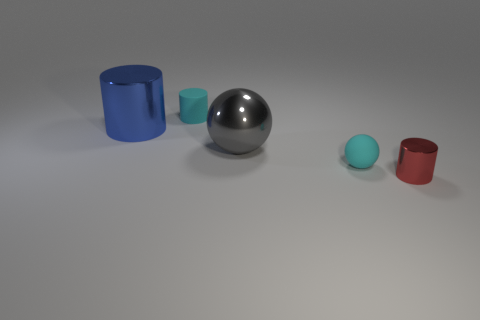What number of things have the same color as the small rubber ball?
Your answer should be very brief. 1. There is a rubber thing that is in front of the tiny object behind the cylinder that is to the left of the rubber cylinder; how big is it?
Ensure brevity in your answer.  Small. How many small cylinders are behind the red metallic cylinder?
Offer a terse response. 1. Is the number of tiny rubber balls greater than the number of brown balls?
Your answer should be very brief. Yes. There is a rubber object that is the same color as the tiny rubber cylinder; what is its size?
Keep it short and to the point. Small. How big is the cylinder that is both in front of the small rubber cylinder and to the left of the matte ball?
Give a very brief answer. Large. There is a tiny cylinder that is in front of the big blue metal object that is behind the big object in front of the blue shiny object; what is its material?
Your answer should be compact. Metal. There is a small object that is the same color as the tiny matte ball; what is it made of?
Your answer should be compact. Rubber. Does the tiny rubber cylinder that is behind the large cylinder have the same color as the large metal thing that is in front of the large cylinder?
Provide a succinct answer. No. There is a large metal object that is on the left side of the tiny thing on the left side of the cyan thing that is to the right of the big ball; what shape is it?
Provide a short and direct response. Cylinder. 